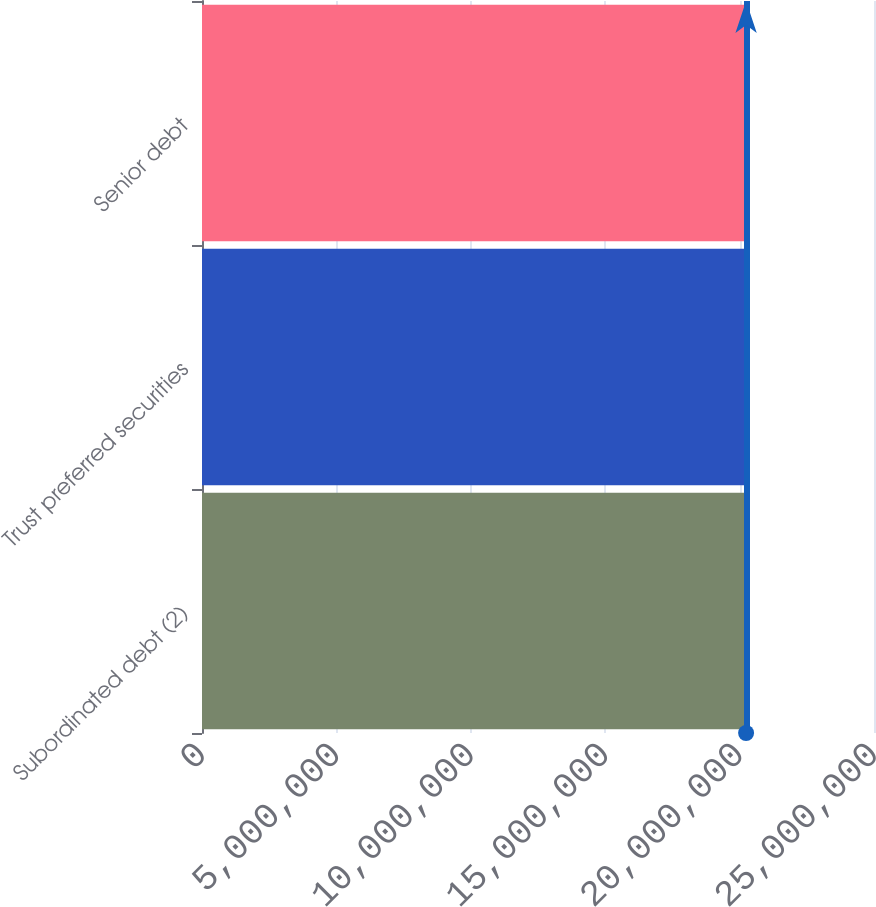<chart> <loc_0><loc_0><loc_500><loc_500><bar_chart><fcel>Subordinated debt (2)<fcel>Trust preferred securities<fcel>Senior debt<nl><fcel>2.0191e+07<fcel>2.03621e+07<fcel>2.0172e+07<nl></chart> 